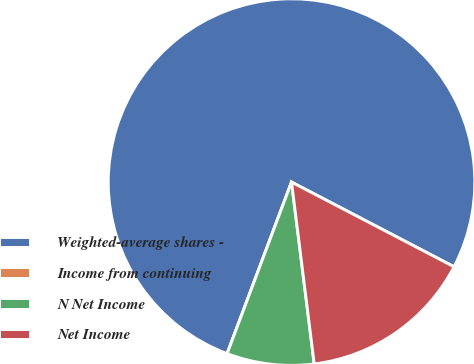<chart> <loc_0><loc_0><loc_500><loc_500><pie_chart><fcel>Weighted-average shares -<fcel>Income from continuing<fcel>N Net Income<fcel>Net Income<nl><fcel>76.92%<fcel>0.0%<fcel>7.69%<fcel>15.38%<nl></chart> 